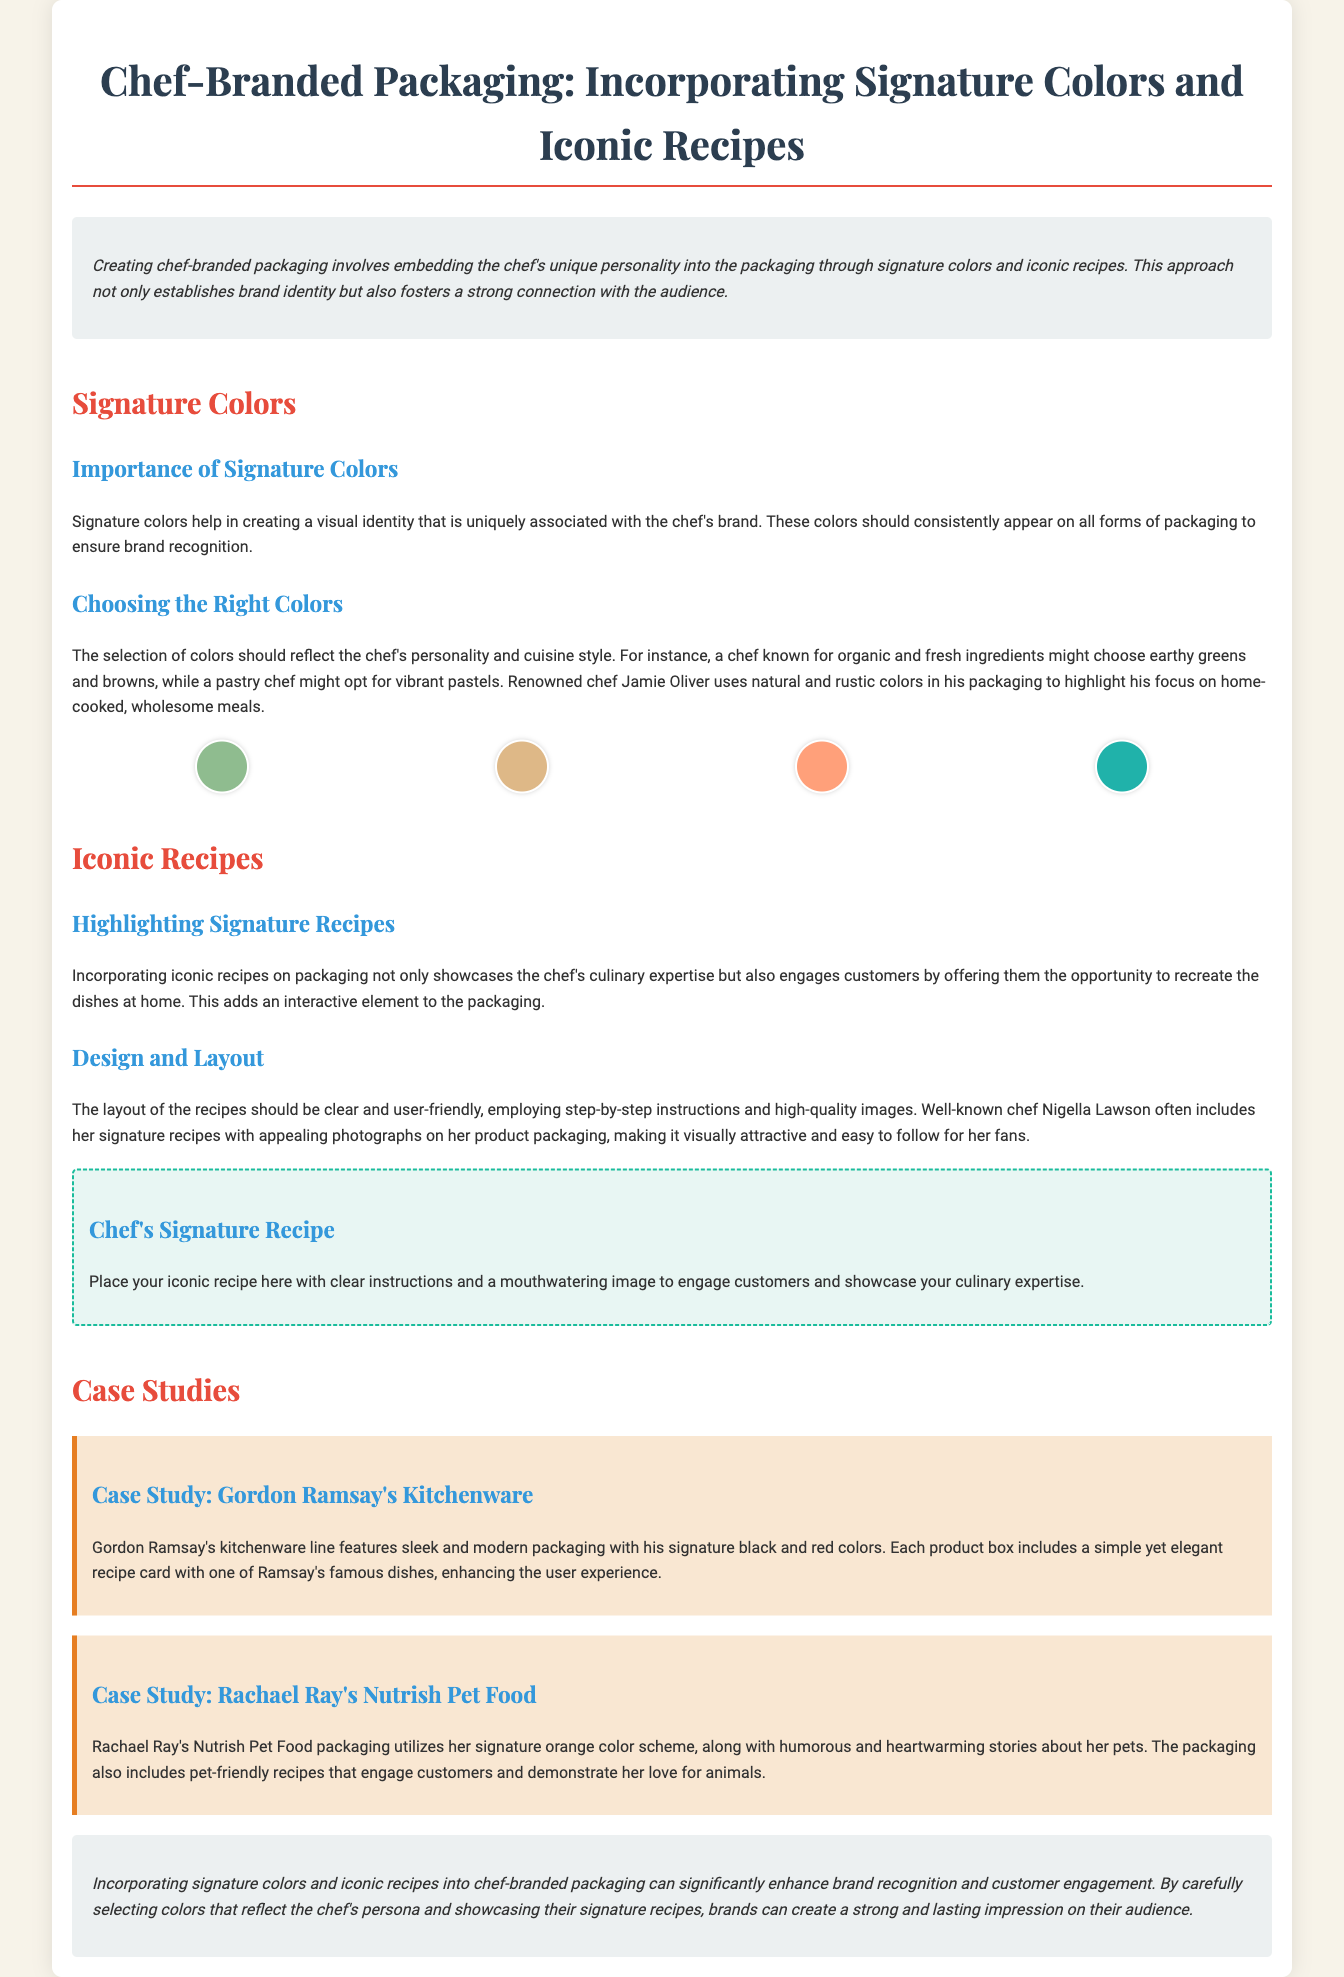What is the main focus of the document? The main focus is on incorporating signature colors and iconic recipes into chef-branded packaging to enhance brand identity and customer connection.
Answer: Incorporating signature colors and iconic recipes What is one example of a chef mentioned? The document provides specific examples of chefs who utilize signature colors and recipes in their branding efforts, including Jamie Oliver.
Answer: Jamie Oliver What color scheme does Rachael Ray use for her packaging? The document states that Rachael Ray's Nutrish Pet Food packaging utilizes her signature orange color scheme.
Answer: Orange What is the benefit of incorporating iconic recipes into packaging? The document highlights that incorporating iconic recipes engages customers by allowing them to recreate dishes at home, adding an interactive element.
Answer: Engaging customers What two colors did Gordon Ramsay choose for his kitchenware packaging? The document states that Gordon Ramsay's kitchenware line features sleek and modern packaging with his signature black and red colors.
Answer: Black and red What is highlighted about Nigella Lawson's packaging design? Nigella Lawson's product packaging includes her signature recipes with appealing photographs, making it visually attractive and easy to follow.
Answer: Appealing photographs How many case studies are discussed in the document? The document discusses two case studies related to chef-branded packaging.
Answer: Two What element does the color palette in the document feature? The color palette displays swatches of different colors that represent the visual identity related to chef branding.
Answer: Color swatches 